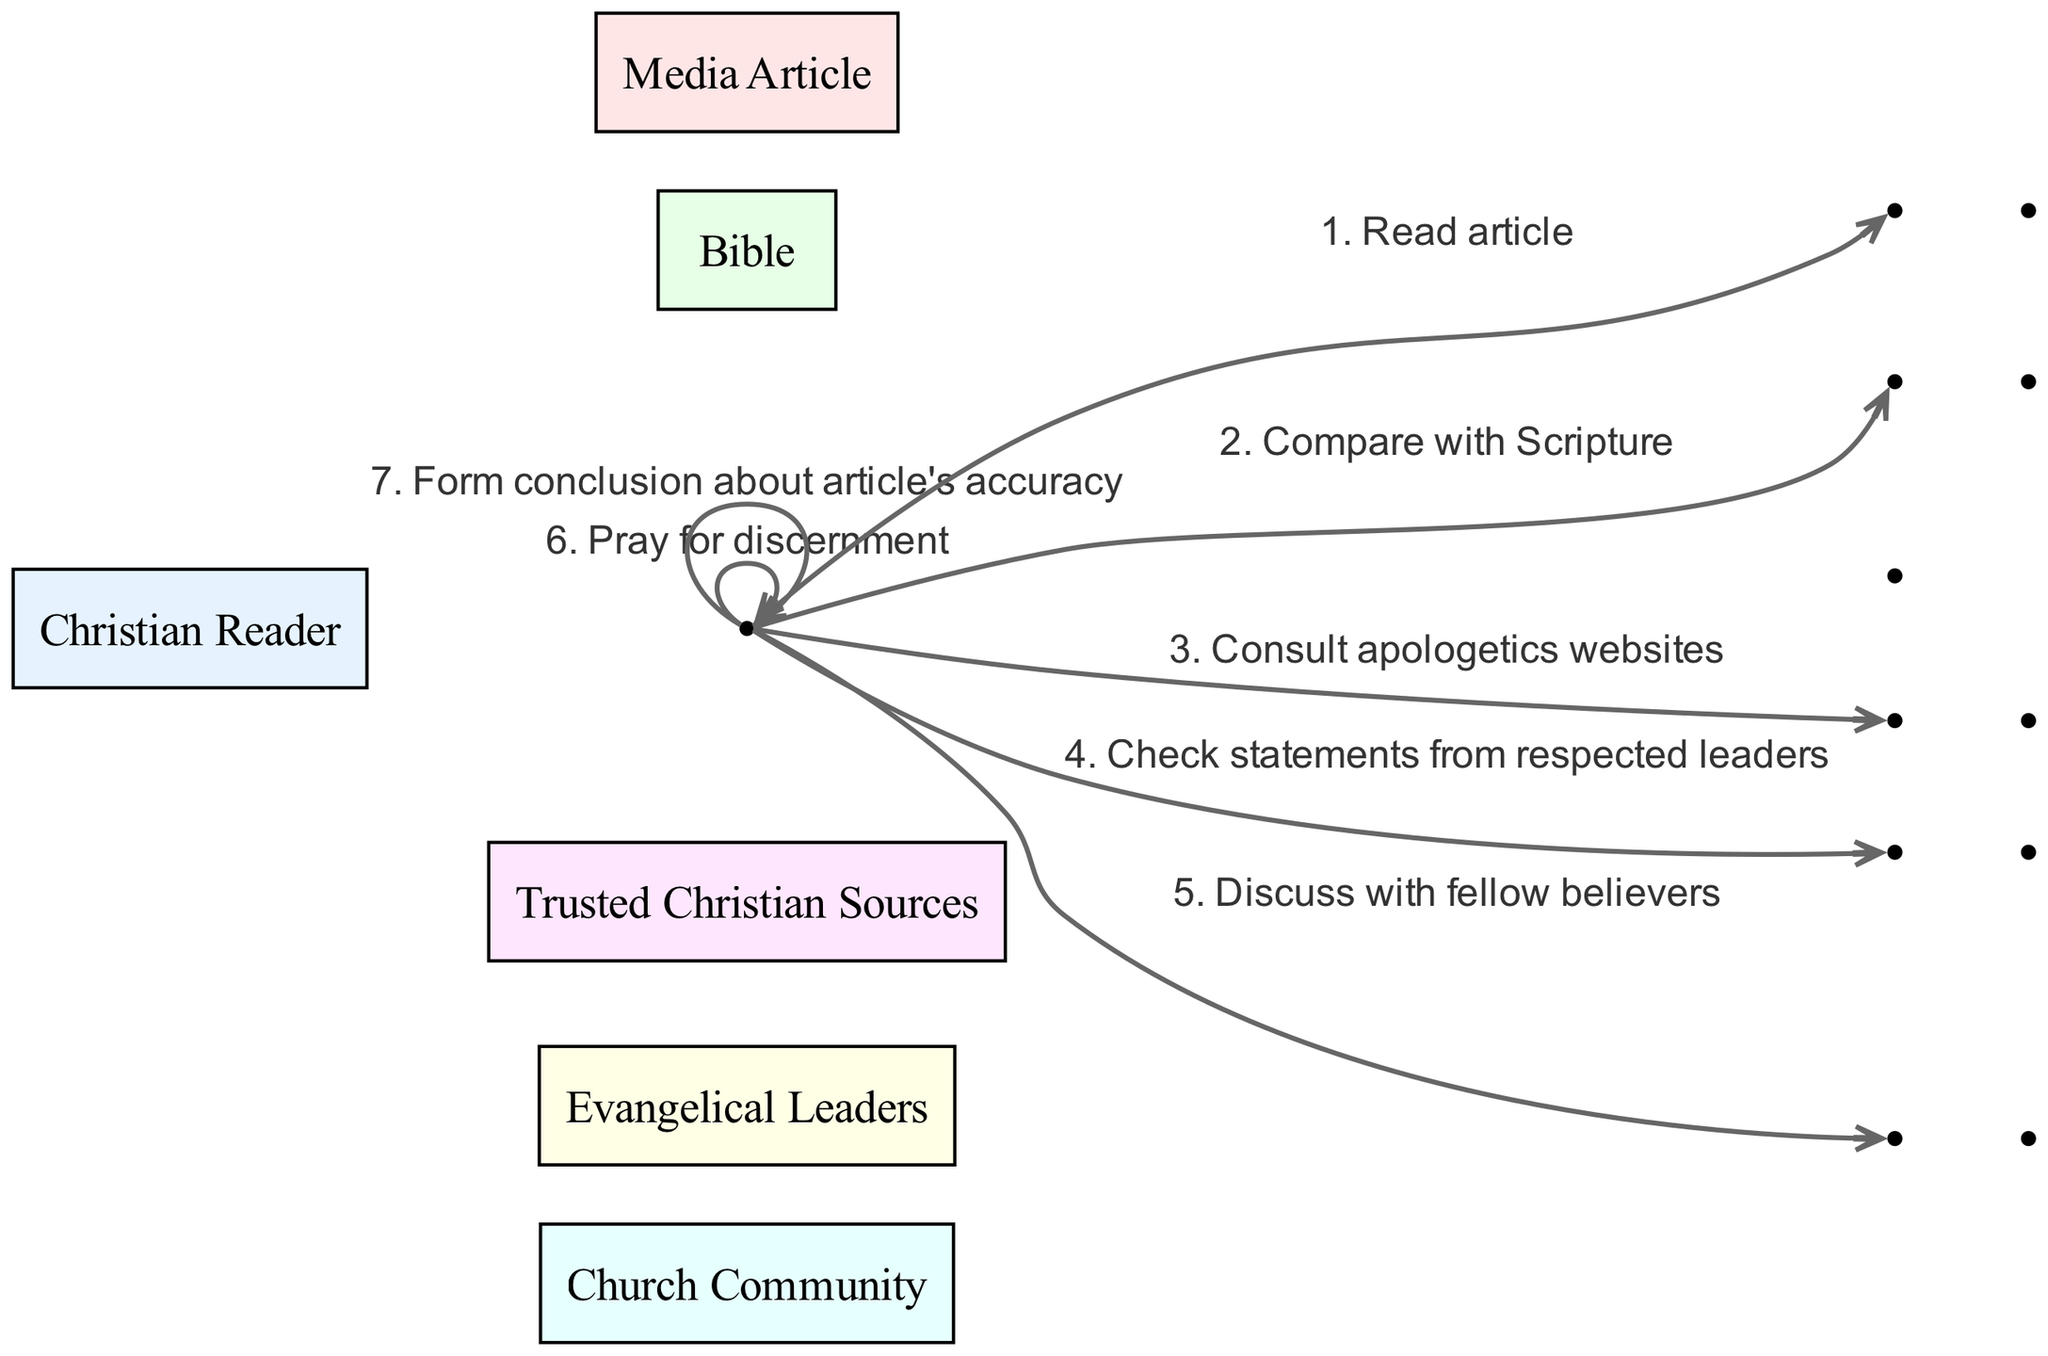What is the total number of participants in the diagram? The diagram lists six distinct participants who are involved in the fact-checking process: Christian Reader, Media Article, Bible, Trusted Christian Sources, Evangelical Leaders, and Church Community. Counting these participants gives a total of six.
Answer: 6 Which participant does the Christian Reader consult after reading the article? The diagram shows that the Christian Reader consults Trusted Christian Sources after reading the Media Article, as indicated by a direct line from the Christian Reader to Trusted Christian Sources.
Answer: Trusted Christian Sources How many actions does the Christian Reader perform? The Christian Reader is shown to engage in a total of six distinct actions throughout the diagram, connected directly to various participants and actions including reading the article, comparing with Scripture, consulting sources, and discussing with fellow believers.
Answer: 6 What is the first action performed by the Christian Reader? The first action reflected in the diagram where the Christian Reader is involved is to read the Media Article. This is the initial step in the sequence of actions.
Answer: Read article Which two participants are consulted to verify statements in the article? The diagram features two specific participants that the Christian Reader consults for verification: Trusted Christian Sources and Evangelical Leaders. The arrows indicate that the Christian Reader checks statements from these two parties.
Answer: Trusted Christian Sources and Evangelical Leaders What does the Christian Reader do after discussing with the Church Community? After discussing with the Church Community, the Christian Reader is shown to pray for discernment, which is the subsequent action taken in the sequence.
Answer: Pray for discernment Which action directly follows "Consult apologetics websites"? Following the action "Consult apologetics websites," the next action taken by the Christian Reader in the sequence is to check statements from respected leaders, as depicted by the directed sequence in the diagram.
Answer: Check statements from respected leaders 